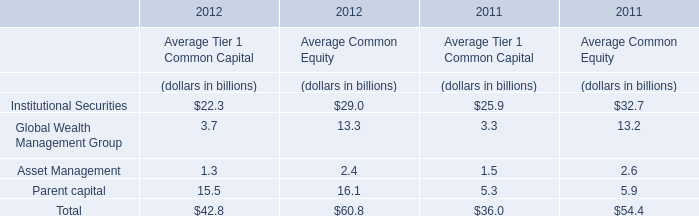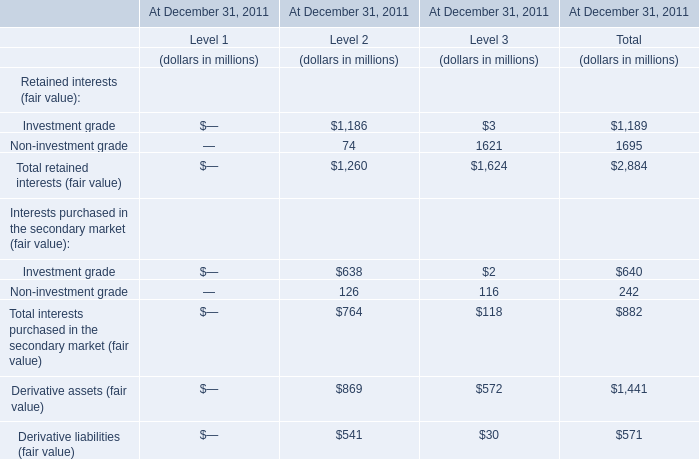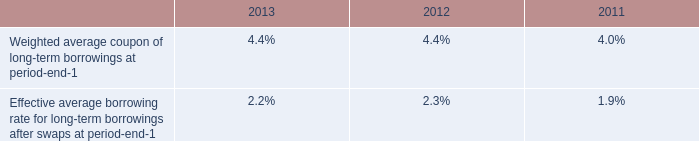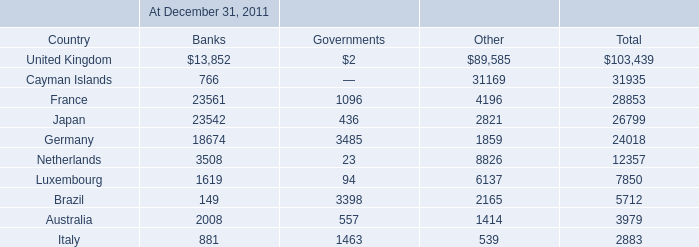Which Level is Interests purchased in the secondary market (fair value) in terms of Investment grade the highest in 2011? 
Answer: 2. 